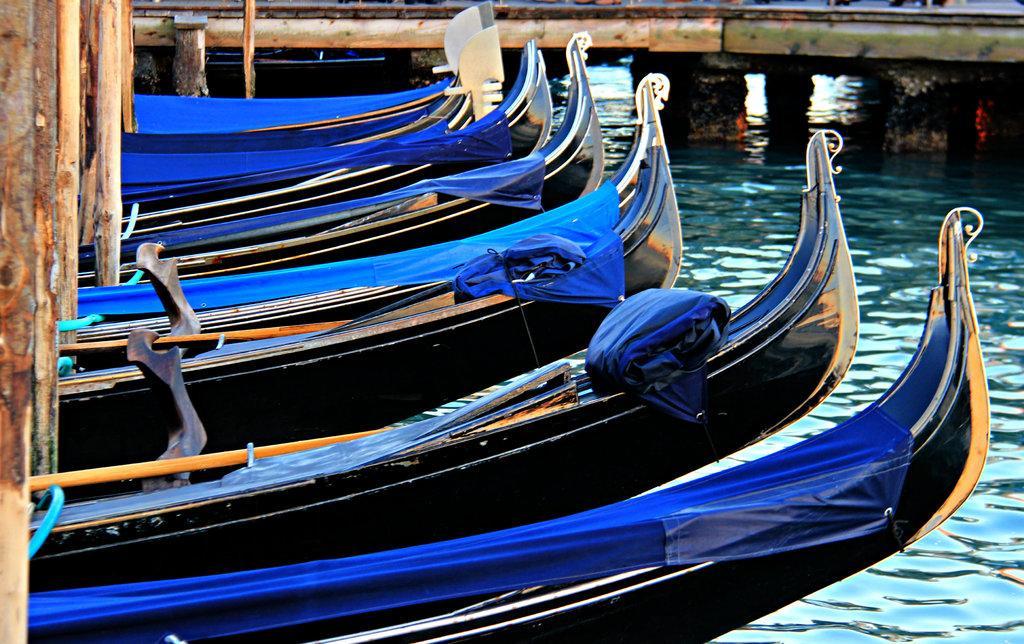Please provide a concise description of this image. In the image we can see there are boats in the water. This is a wooden pole, water and paddles. 